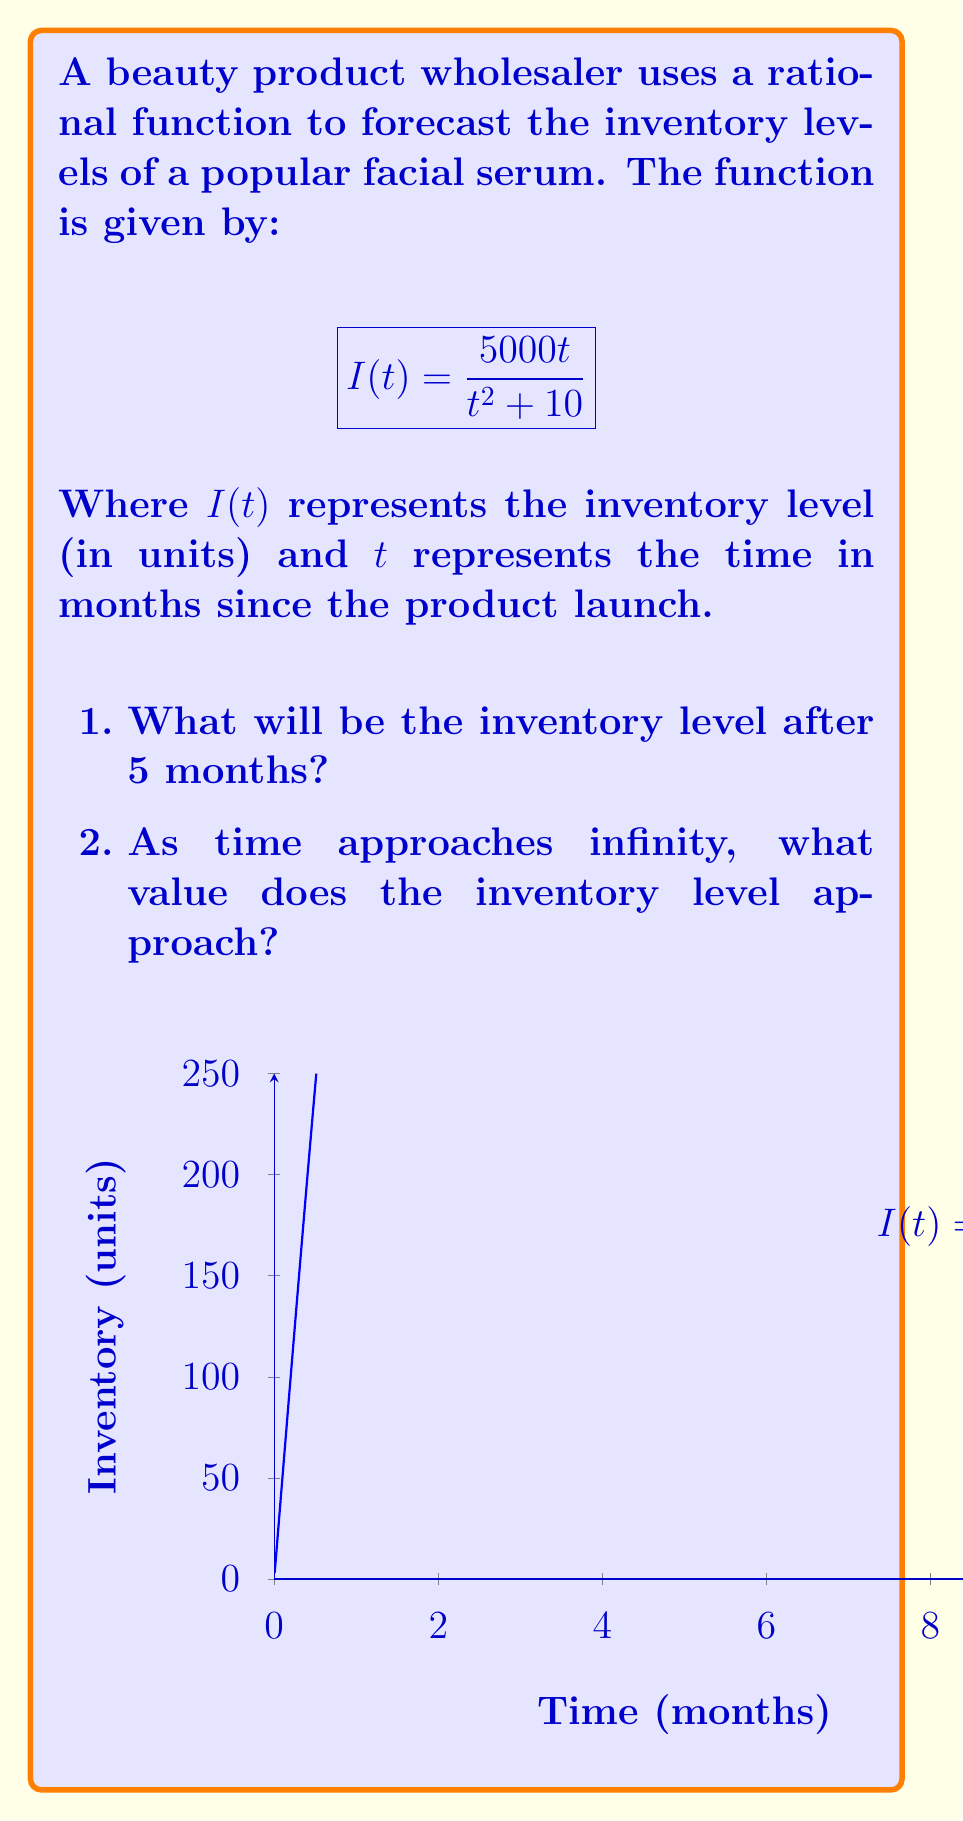Provide a solution to this math problem. Let's approach this problem step by step:

1. To find the inventory level after 5 months, we need to evaluate $I(5)$:

   $$I(5) = \frac{5000(5)}{5^2 + 10} = \frac{25000}{25 + 10} = \frac{25000}{35} \approx 714.29$$

   So, after 5 months, the inventory level will be approximately 714 units.

2. To find the limit as time approaches infinity, we need to evaluate:

   $$\lim_{t \to \infty} \frac{5000t}{t^2 + 10}$$

   We can solve this by dividing both numerator and denominator by the highest power of $t$ in the denominator, which is $t^2$:

   $$\lim_{t \to \infty} \frac{5000t/t^2}{(t^2 + 10)/t^2} = \lim_{t \to \infty} \frac{5000/t}{1 + 10/t^2}$$

   As $t$ approaches infinity, $1/t$ and $10/t^2$ approach 0:

   $$\lim_{t \to \infty} \frac{5000/t}{1 + 10/t^2} = \frac{0}{1} = 0$$

   Therefore, as time approaches infinity, the inventory level approaches 0 units.

This rational model suggests that the inventory will peak and then gradually decrease over time, which could represent a product lifecycle where demand eventually diminishes.
Answer: 1. 714 units
2. 0 units 